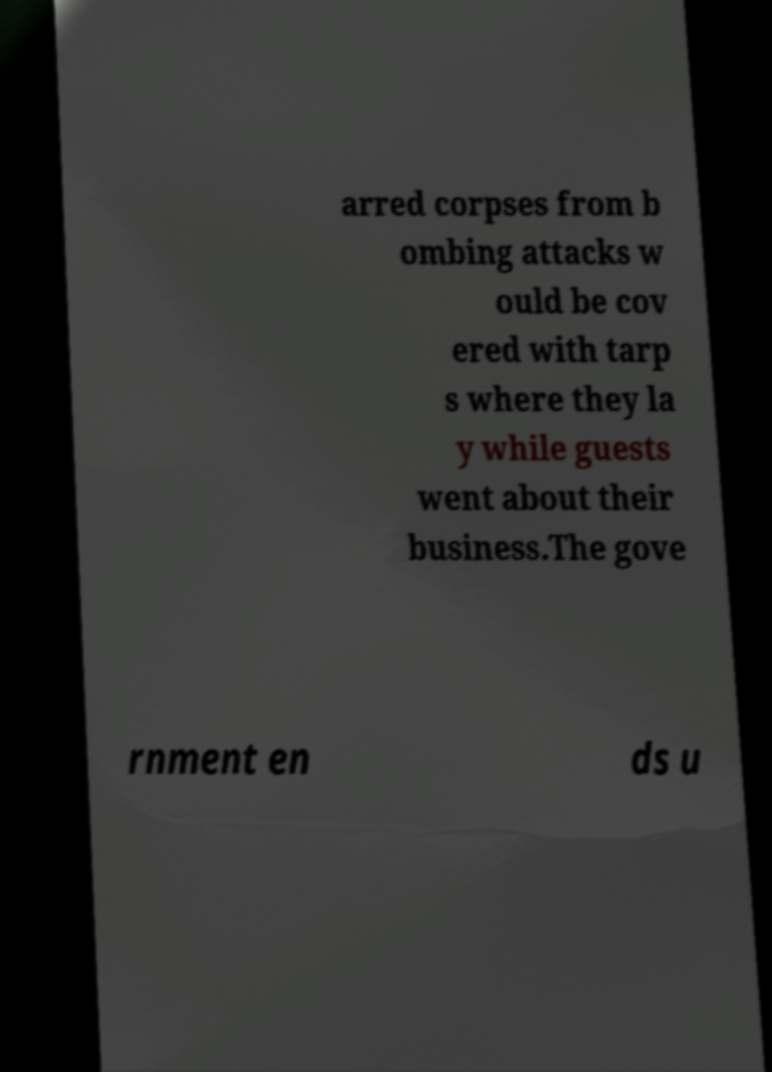Please identify and transcribe the text found in this image. arred corpses from b ombing attacks w ould be cov ered with tarp s where they la y while guests went about their business.The gove rnment en ds u 